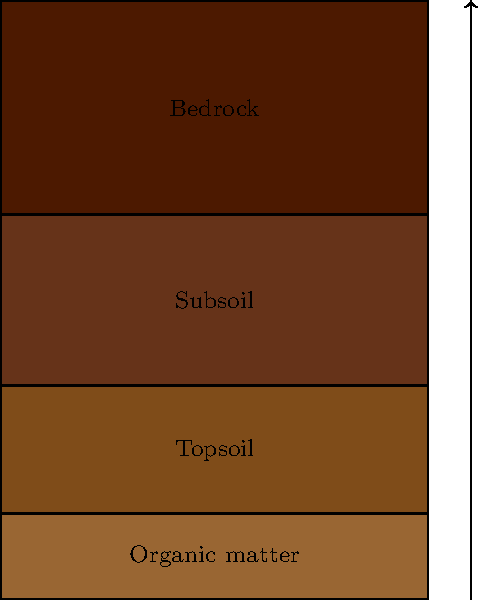In sustainable farming practices, which soil layer is most critical for nutrient cycling and carbon sequestration, and how can farmers enhance its health to improve overall soil quality and environmental sustainability? To answer this question, let's break down the soil profile and the importance of each layer in sustainable farming:

1. Organic matter layer:
   - Thin layer on top of the soil
   - Composed of decomposing plant and animal matter
   - Important for nutrient cycling but not the most critical layer

2. Topsoil layer:
   - This is the most critical layer for sustainable farming
   - Contains the highest concentration of organic matter and microorganisms
   - Key for nutrient cycling and carbon sequestration
   - Typically 5-30 cm deep

3. Subsoil layer:
   - Contains less organic matter but is important for water retention
   - Provides minerals and nutrients to plant roots

4. Bedrock layer:
   - Parent material for soil formation
   - Not directly involved in nutrient cycling or carbon sequestration

To enhance the health of the topsoil layer and improve overall soil quality:

a) Implement crop rotation to maintain soil fertility and reduce pest pressure
b) Use cover crops to prevent erosion and add organic matter
c) Minimize tillage to preserve soil structure and microbial communities
d) Apply compost or organic mulches to increase organic matter content
e) Avoid overuse of chemical fertilizers and pesticides that can harm soil microorganisms
f) Manage livestock grazing to prevent soil compaction and overgrazing

By focusing on these practices, farmers can enhance the topsoil layer's health, which in turn improves nutrient cycling, carbon sequestration, and overall environmental sustainability.
Answer: Topsoil; enhance through crop rotation, cover crops, minimal tillage, organic matter addition, and reduced chemical inputs. 